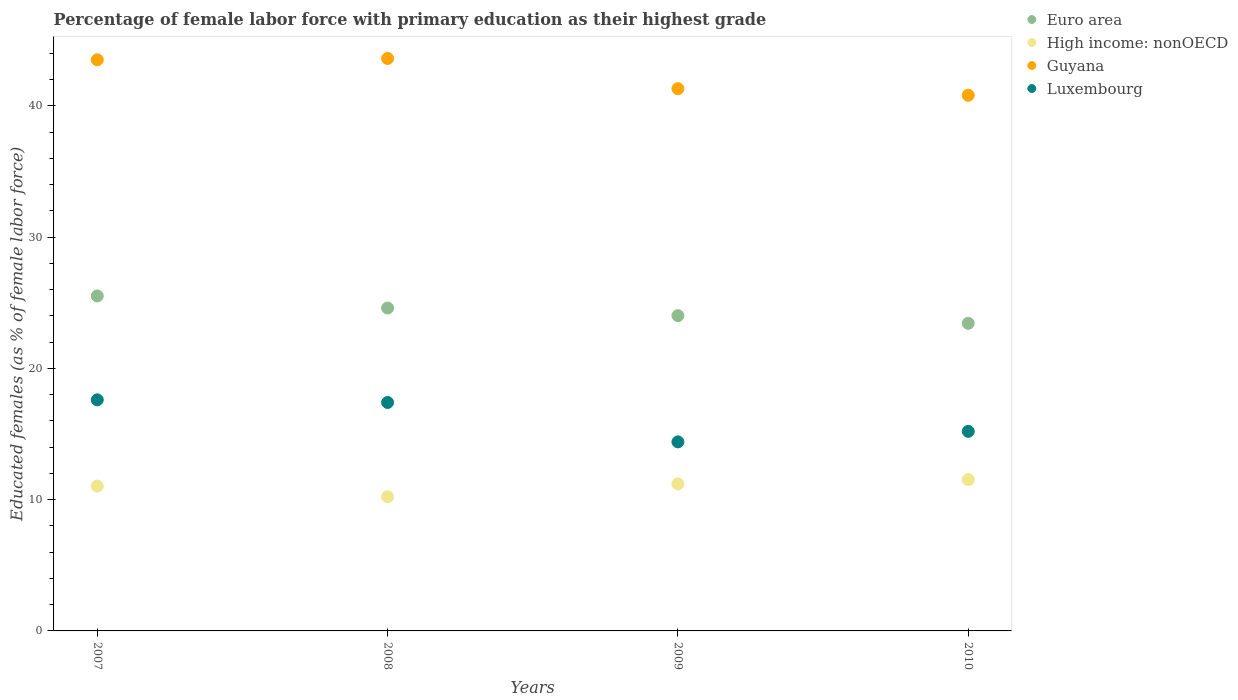What is the percentage of female labor force with primary education in Luxembourg in 2010?
Keep it short and to the point. 15.2. Across all years, what is the maximum percentage of female labor force with primary education in Euro area?
Offer a terse response. 25.51. Across all years, what is the minimum percentage of female labor force with primary education in Euro area?
Your response must be concise. 23.43. In which year was the percentage of female labor force with primary education in Luxembourg minimum?
Provide a short and direct response. 2009. What is the total percentage of female labor force with primary education in Euro area in the graph?
Provide a short and direct response. 97.55. What is the difference between the percentage of female labor force with primary education in Euro area in 2007 and that in 2009?
Your response must be concise. 1.5. What is the difference between the percentage of female labor force with primary education in Luxembourg in 2010 and the percentage of female labor force with primary education in High income: nonOECD in 2007?
Provide a short and direct response. 4.17. What is the average percentage of female labor force with primary education in Luxembourg per year?
Your answer should be very brief. 16.15. In the year 2009, what is the difference between the percentage of female labor force with primary education in Euro area and percentage of female labor force with primary education in Guyana?
Provide a short and direct response. -17.29. In how many years, is the percentage of female labor force with primary education in Luxembourg greater than 40 %?
Your response must be concise. 0. What is the ratio of the percentage of female labor force with primary education in Guyana in 2009 to that in 2010?
Give a very brief answer. 1.01. What is the difference between the highest and the second highest percentage of female labor force with primary education in Luxembourg?
Offer a terse response. 0.2. What is the difference between the highest and the lowest percentage of female labor force with primary education in Guyana?
Your answer should be compact. 2.8. Is the sum of the percentage of female labor force with primary education in High income: nonOECD in 2007 and 2010 greater than the maximum percentage of female labor force with primary education in Guyana across all years?
Provide a succinct answer. No. How many dotlines are there?
Your response must be concise. 4. What is the difference between two consecutive major ticks on the Y-axis?
Your answer should be compact. 10. Are the values on the major ticks of Y-axis written in scientific E-notation?
Offer a terse response. No. Does the graph contain any zero values?
Provide a succinct answer. No. What is the title of the graph?
Make the answer very short. Percentage of female labor force with primary education as their highest grade. Does "Cambodia" appear as one of the legend labels in the graph?
Offer a terse response. No. What is the label or title of the Y-axis?
Your answer should be very brief. Educated females (as % of female labor force). What is the Educated females (as % of female labor force) of Euro area in 2007?
Your answer should be compact. 25.51. What is the Educated females (as % of female labor force) of High income: nonOECD in 2007?
Offer a terse response. 11.03. What is the Educated females (as % of female labor force) in Guyana in 2007?
Keep it short and to the point. 43.5. What is the Educated females (as % of female labor force) of Luxembourg in 2007?
Provide a short and direct response. 17.6. What is the Educated females (as % of female labor force) in Euro area in 2008?
Provide a short and direct response. 24.59. What is the Educated females (as % of female labor force) in High income: nonOECD in 2008?
Keep it short and to the point. 10.21. What is the Educated females (as % of female labor force) of Guyana in 2008?
Offer a very short reply. 43.6. What is the Educated females (as % of female labor force) in Luxembourg in 2008?
Offer a very short reply. 17.4. What is the Educated females (as % of female labor force) of Euro area in 2009?
Offer a terse response. 24.01. What is the Educated females (as % of female labor force) of High income: nonOECD in 2009?
Your response must be concise. 11.2. What is the Educated females (as % of female labor force) of Guyana in 2009?
Offer a terse response. 41.3. What is the Educated females (as % of female labor force) in Luxembourg in 2009?
Provide a short and direct response. 14.4. What is the Educated females (as % of female labor force) in Euro area in 2010?
Your response must be concise. 23.43. What is the Educated females (as % of female labor force) in High income: nonOECD in 2010?
Your response must be concise. 11.53. What is the Educated females (as % of female labor force) of Guyana in 2010?
Ensure brevity in your answer.  40.8. What is the Educated females (as % of female labor force) in Luxembourg in 2010?
Give a very brief answer. 15.2. Across all years, what is the maximum Educated females (as % of female labor force) of Euro area?
Ensure brevity in your answer.  25.51. Across all years, what is the maximum Educated females (as % of female labor force) of High income: nonOECD?
Make the answer very short. 11.53. Across all years, what is the maximum Educated females (as % of female labor force) of Guyana?
Your response must be concise. 43.6. Across all years, what is the maximum Educated females (as % of female labor force) in Luxembourg?
Your answer should be very brief. 17.6. Across all years, what is the minimum Educated females (as % of female labor force) of Euro area?
Your response must be concise. 23.43. Across all years, what is the minimum Educated females (as % of female labor force) in High income: nonOECD?
Offer a very short reply. 10.21. Across all years, what is the minimum Educated females (as % of female labor force) of Guyana?
Your answer should be compact. 40.8. Across all years, what is the minimum Educated females (as % of female labor force) of Luxembourg?
Your answer should be compact. 14.4. What is the total Educated females (as % of female labor force) in Euro area in the graph?
Keep it short and to the point. 97.55. What is the total Educated females (as % of female labor force) in High income: nonOECD in the graph?
Your answer should be very brief. 43.97. What is the total Educated females (as % of female labor force) in Guyana in the graph?
Offer a very short reply. 169.2. What is the total Educated females (as % of female labor force) of Luxembourg in the graph?
Offer a terse response. 64.6. What is the difference between the Educated females (as % of female labor force) in Euro area in 2007 and that in 2008?
Make the answer very short. 0.92. What is the difference between the Educated females (as % of female labor force) of High income: nonOECD in 2007 and that in 2008?
Provide a succinct answer. 0.82. What is the difference between the Educated females (as % of female labor force) in Euro area in 2007 and that in 2009?
Your answer should be very brief. 1.5. What is the difference between the Educated females (as % of female labor force) in High income: nonOECD in 2007 and that in 2009?
Make the answer very short. -0.17. What is the difference between the Educated females (as % of female labor force) of Guyana in 2007 and that in 2009?
Provide a succinct answer. 2.2. What is the difference between the Educated females (as % of female labor force) of Euro area in 2007 and that in 2010?
Your answer should be very brief. 2.08. What is the difference between the Educated females (as % of female labor force) of High income: nonOECD in 2007 and that in 2010?
Give a very brief answer. -0.49. What is the difference between the Educated females (as % of female labor force) of Luxembourg in 2007 and that in 2010?
Your answer should be very brief. 2.4. What is the difference between the Educated females (as % of female labor force) of Euro area in 2008 and that in 2009?
Provide a succinct answer. 0.58. What is the difference between the Educated females (as % of female labor force) of High income: nonOECD in 2008 and that in 2009?
Offer a very short reply. -0.99. What is the difference between the Educated females (as % of female labor force) of Guyana in 2008 and that in 2009?
Provide a succinct answer. 2.3. What is the difference between the Educated females (as % of female labor force) of Luxembourg in 2008 and that in 2009?
Provide a short and direct response. 3. What is the difference between the Educated females (as % of female labor force) of Euro area in 2008 and that in 2010?
Make the answer very short. 1.17. What is the difference between the Educated females (as % of female labor force) of High income: nonOECD in 2008 and that in 2010?
Offer a terse response. -1.31. What is the difference between the Educated females (as % of female labor force) of Luxembourg in 2008 and that in 2010?
Make the answer very short. 2.2. What is the difference between the Educated females (as % of female labor force) of Euro area in 2009 and that in 2010?
Offer a very short reply. 0.58. What is the difference between the Educated females (as % of female labor force) of High income: nonOECD in 2009 and that in 2010?
Provide a succinct answer. -0.33. What is the difference between the Educated females (as % of female labor force) of Euro area in 2007 and the Educated females (as % of female labor force) of High income: nonOECD in 2008?
Your answer should be compact. 15.3. What is the difference between the Educated females (as % of female labor force) of Euro area in 2007 and the Educated females (as % of female labor force) of Guyana in 2008?
Your response must be concise. -18.09. What is the difference between the Educated females (as % of female labor force) in Euro area in 2007 and the Educated females (as % of female labor force) in Luxembourg in 2008?
Offer a very short reply. 8.11. What is the difference between the Educated females (as % of female labor force) in High income: nonOECD in 2007 and the Educated females (as % of female labor force) in Guyana in 2008?
Make the answer very short. -32.57. What is the difference between the Educated females (as % of female labor force) in High income: nonOECD in 2007 and the Educated females (as % of female labor force) in Luxembourg in 2008?
Keep it short and to the point. -6.37. What is the difference between the Educated females (as % of female labor force) of Guyana in 2007 and the Educated females (as % of female labor force) of Luxembourg in 2008?
Offer a very short reply. 26.1. What is the difference between the Educated females (as % of female labor force) in Euro area in 2007 and the Educated females (as % of female labor force) in High income: nonOECD in 2009?
Ensure brevity in your answer.  14.31. What is the difference between the Educated females (as % of female labor force) of Euro area in 2007 and the Educated females (as % of female labor force) of Guyana in 2009?
Keep it short and to the point. -15.79. What is the difference between the Educated females (as % of female labor force) of Euro area in 2007 and the Educated females (as % of female labor force) of Luxembourg in 2009?
Keep it short and to the point. 11.11. What is the difference between the Educated females (as % of female labor force) in High income: nonOECD in 2007 and the Educated females (as % of female labor force) in Guyana in 2009?
Offer a very short reply. -30.27. What is the difference between the Educated females (as % of female labor force) of High income: nonOECD in 2007 and the Educated females (as % of female labor force) of Luxembourg in 2009?
Provide a short and direct response. -3.37. What is the difference between the Educated females (as % of female labor force) in Guyana in 2007 and the Educated females (as % of female labor force) in Luxembourg in 2009?
Provide a succinct answer. 29.1. What is the difference between the Educated females (as % of female labor force) in Euro area in 2007 and the Educated females (as % of female labor force) in High income: nonOECD in 2010?
Your answer should be very brief. 13.99. What is the difference between the Educated females (as % of female labor force) in Euro area in 2007 and the Educated females (as % of female labor force) in Guyana in 2010?
Give a very brief answer. -15.29. What is the difference between the Educated females (as % of female labor force) in Euro area in 2007 and the Educated females (as % of female labor force) in Luxembourg in 2010?
Give a very brief answer. 10.31. What is the difference between the Educated females (as % of female labor force) of High income: nonOECD in 2007 and the Educated females (as % of female labor force) of Guyana in 2010?
Give a very brief answer. -29.77. What is the difference between the Educated females (as % of female labor force) in High income: nonOECD in 2007 and the Educated females (as % of female labor force) in Luxembourg in 2010?
Offer a terse response. -4.17. What is the difference between the Educated females (as % of female labor force) in Guyana in 2007 and the Educated females (as % of female labor force) in Luxembourg in 2010?
Make the answer very short. 28.3. What is the difference between the Educated females (as % of female labor force) in Euro area in 2008 and the Educated females (as % of female labor force) in High income: nonOECD in 2009?
Your answer should be very brief. 13.39. What is the difference between the Educated females (as % of female labor force) of Euro area in 2008 and the Educated females (as % of female labor force) of Guyana in 2009?
Make the answer very short. -16.71. What is the difference between the Educated females (as % of female labor force) in Euro area in 2008 and the Educated females (as % of female labor force) in Luxembourg in 2009?
Provide a succinct answer. 10.19. What is the difference between the Educated females (as % of female labor force) of High income: nonOECD in 2008 and the Educated females (as % of female labor force) of Guyana in 2009?
Provide a succinct answer. -31.09. What is the difference between the Educated females (as % of female labor force) in High income: nonOECD in 2008 and the Educated females (as % of female labor force) in Luxembourg in 2009?
Give a very brief answer. -4.19. What is the difference between the Educated females (as % of female labor force) of Guyana in 2008 and the Educated females (as % of female labor force) of Luxembourg in 2009?
Offer a very short reply. 29.2. What is the difference between the Educated females (as % of female labor force) in Euro area in 2008 and the Educated females (as % of female labor force) in High income: nonOECD in 2010?
Keep it short and to the point. 13.07. What is the difference between the Educated females (as % of female labor force) in Euro area in 2008 and the Educated females (as % of female labor force) in Guyana in 2010?
Make the answer very short. -16.21. What is the difference between the Educated females (as % of female labor force) of Euro area in 2008 and the Educated females (as % of female labor force) of Luxembourg in 2010?
Provide a succinct answer. 9.39. What is the difference between the Educated females (as % of female labor force) in High income: nonOECD in 2008 and the Educated females (as % of female labor force) in Guyana in 2010?
Keep it short and to the point. -30.59. What is the difference between the Educated females (as % of female labor force) of High income: nonOECD in 2008 and the Educated females (as % of female labor force) of Luxembourg in 2010?
Provide a succinct answer. -4.99. What is the difference between the Educated females (as % of female labor force) of Guyana in 2008 and the Educated females (as % of female labor force) of Luxembourg in 2010?
Provide a short and direct response. 28.4. What is the difference between the Educated females (as % of female labor force) in Euro area in 2009 and the Educated females (as % of female labor force) in High income: nonOECD in 2010?
Give a very brief answer. 12.49. What is the difference between the Educated females (as % of female labor force) of Euro area in 2009 and the Educated females (as % of female labor force) of Guyana in 2010?
Your answer should be very brief. -16.79. What is the difference between the Educated females (as % of female labor force) of Euro area in 2009 and the Educated females (as % of female labor force) of Luxembourg in 2010?
Your answer should be very brief. 8.81. What is the difference between the Educated females (as % of female labor force) in High income: nonOECD in 2009 and the Educated females (as % of female labor force) in Guyana in 2010?
Offer a terse response. -29.6. What is the difference between the Educated females (as % of female labor force) of High income: nonOECD in 2009 and the Educated females (as % of female labor force) of Luxembourg in 2010?
Your response must be concise. -4. What is the difference between the Educated females (as % of female labor force) in Guyana in 2009 and the Educated females (as % of female labor force) in Luxembourg in 2010?
Provide a short and direct response. 26.1. What is the average Educated females (as % of female labor force) in Euro area per year?
Ensure brevity in your answer.  24.39. What is the average Educated females (as % of female labor force) in High income: nonOECD per year?
Your answer should be compact. 10.99. What is the average Educated females (as % of female labor force) in Guyana per year?
Keep it short and to the point. 42.3. What is the average Educated females (as % of female labor force) in Luxembourg per year?
Ensure brevity in your answer.  16.15. In the year 2007, what is the difference between the Educated females (as % of female labor force) in Euro area and Educated females (as % of female labor force) in High income: nonOECD?
Your answer should be very brief. 14.48. In the year 2007, what is the difference between the Educated females (as % of female labor force) of Euro area and Educated females (as % of female labor force) of Guyana?
Keep it short and to the point. -17.99. In the year 2007, what is the difference between the Educated females (as % of female labor force) in Euro area and Educated females (as % of female labor force) in Luxembourg?
Offer a terse response. 7.91. In the year 2007, what is the difference between the Educated females (as % of female labor force) of High income: nonOECD and Educated females (as % of female labor force) of Guyana?
Offer a terse response. -32.47. In the year 2007, what is the difference between the Educated females (as % of female labor force) in High income: nonOECD and Educated females (as % of female labor force) in Luxembourg?
Your response must be concise. -6.57. In the year 2007, what is the difference between the Educated females (as % of female labor force) in Guyana and Educated females (as % of female labor force) in Luxembourg?
Offer a very short reply. 25.9. In the year 2008, what is the difference between the Educated females (as % of female labor force) in Euro area and Educated females (as % of female labor force) in High income: nonOECD?
Give a very brief answer. 14.38. In the year 2008, what is the difference between the Educated females (as % of female labor force) of Euro area and Educated females (as % of female labor force) of Guyana?
Your answer should be compact. -19.01. In the year 2008, what is the difference between the Educated females (as % of female labor force) in Euro area and Educated females (as % of female labor force) in Luxembourg?
Your answer should be very brief. 7.19. In the year 2008, what is the difference between the Educated females (as % of female labor force) of High income: nonOECD and Educated females (as % of female labor force) of Guyana?
Provide a short and direct response. -33.39. In the year 2008, what is the difference between the Educated females (as % of female labor force) in High income: nonOECD and Educated females (as % of female labor force) in Luxembourg?
Keep it short and to the point. -7.19. In the year 2008, what is the difference between the Educated females (as % of female labor force) in Guyana and Educated females (as % of female labor force) in Luxembourg?
Your answer should be compact. 26.2. In the year 2009, what is the difference between the Educated females (as % of female labor force) in Euro area and Educated females (as % of female labor force) in High income: nonOECD?
Provide a short and direct response. 12.81. In the year 2009, what is the difference between the Educated females (as % of female labor force) of Euro area and Educated females (as % of female labor force) of Guyana?
Keep it short and to the point. -17.29. In the year 2009, what is the difference between the Educated females (as % of female labor force) of Euro area and Educated females (as % of female labor force) of Luxembourg?
Your answer should be compact. 9.61. In the year 2009, what is the difference between the Educated females (as % of female labor force) in High income: nonOECD and Educated females (as % of female labor force) in Guyana?
Provide a short and direct response. -30.1. In the year 2009, what is the difference between the Educated females (as % of female labor force) in High income: nonOECD and Educated females (as % of female labor force) in Luxembourg?
Offer a very short reply. -3.2. In the year 2009, what is the difference between the Educated females (as % of female labor force) of Guyana and Educated females (as % of female labor force) of Luxembourg?
Provide a short and direct response. 26.9. In the year 2010, what is the difference between the Educated females (as % of female labor force) in Euro area and Educated females (as % of female labor force) in High income: nonOECD?
Keep it short and to the point. 11.9. In the year 2010, what is the difference between the Educated females (as % of female labor force) in Euro area and Educated females (as % of female labor force) in Guyana?
Your response must be concise. -17.37. In the year 2010, what is the difference between the Educated females (as % of female labor force) in Euro area and Educated females (as % of female labor force) in Luxembourg?
Give a very brief answer. 8.23. In the year 2010, what is the difference between the Educated females (as % of female labor force) in High income: nonOECD and Educated females (as % of female labor force) in Guyana?
Keep it short and to the point. -29.27. In the year 2010, what is the difference between the Educated females (as % of female labor force) in High income: nonOECD and Educated females (as % of female labor force) in Luxembourg?
Your answer should be compact. -3.67. In the year 2010, what is the difference between the Educated females (as % of female labor force) of Guyana and Educated females (as % of female labor force) of Luxembourg?
Provide a short and direct response. 25.6. What is the ratio of the Educated females (as % of female labor force) in Euro area in 2007 to that in 2008?
Keep it short and to the point. 1.04. What is the ratio of the Educated females (as % of female labor force) of High income: nonOECD in 2007 to that in 2008?
Your response must be concise. 1.08. What is the ratio of the Educated females (as % of female labor force) in Luxembourg in 2007 to that in 2008?
Offer a terse response. 1.01. What is the ratio of the Educated females (as % of female labor force) in Euro area in 2007 to that in 2009?
Make the answer very short. 1.06. What is the ratio of the Educated females (as % of female labor force) in Guyana in 2007 to that in 2009?
Your answer should be compact. 1.05. What is the ratio of the Educated females (as % of female labor force) in Luxembourg in 2007 to that in 2009?
Provide a short and direct response. 1.22. What is the ratio of the Educated females (as % of female labor force) of Euro area in 2007 to that in 2010?
Provide a short and direct response. 1.09. What is the ratio of the Educated females (as % of female labor force) of High income: nonOECD in 2007 to that in 2010?
Make the answer very short. 0.96. What is the ratio of the Educated females (as % of female labor force) in Guyana in 2007 to that in 2010?
Your answer should be very brief. 1.07. What is the ratio of the Educated females (as % of female labor force) of Luxembourg in 2007 to that in 2010?
Give a very brief answer. 1.16. What is the ratio of the Educated females (as % of female labor force) of Euro area in 2008 to that in 2009?
Provide a succinct answer. 1.02. What is the ratio of the Educated females (as % of female labor force) in High income: nonOECD in 2008 to that in 2009?
Ensure brevity in your answer.  0.91. What is the ratio of the Educated females (as % of female labor force) in Guyana in 2008 to that in 2009?
Provide a short and direct response. 1.06. What is the ratio of the Educated females (as % of female labor force) in Luxembourg in 2008 to that in 2009?
Your response must be concise. 1.21. What is the ratio of the Educated females (as % of female labor force) of Euro area in 2008 to that in 2010?
Your answer should be compact. 1.05. What is the ratio of the Educated females (as % of female labor force) of High income: nonOECD in 2008 to that in 2010?
Your response must be concise. 0.89. What is the ratio of the Educated females (as % of female labor force) of Guyana in 2008 to that in 2010?
Keep it short and to the point. 1.07. What is the ratio of the Educated females (as % of female labor force) in Luxembourg in 2008 to that in 2010?
Offer a very short reply. 1.14. What is the ratio of the Educated females (as % of female labor force) of High income: nonOECD in 2009 to that in 2010?
Your answer should be compact. 0.97. What is the ratio of the Educated females (as % of female labor force) of Guyana in 2009 to that in 2010?
Provide a succinct answer. 1.01. What is the difference between the highest and the second highest Educated females (as % of female labor force) of Euro area?
Provide a succinct answer. 0.92. What is the difference between the highest and the second highest Educated females (as % of female labor force) in High income: nonOECD?
Offer a terse response. 0.33. What is the difference between the highest and the second highest Educated females (as % of female labor force) of Guyana?
Keep it short and to the point. 0.1. What is the difference between the highest and the second highest Educated females (as % of female labor force) in Luxembourg?
Offer a terse response. 0.2. What is the difference between the highest and the lowest Educated females (as % of female labor force) of Euro area?
Offer a very short reply. 2.08. What is the difference between the highest and the lowest Educated females (as % of female labor force) in High income: nonOECD?
Provide a short and direct response. 1.31. What is the difference between the highest and the lowest Educated females (as % of female labor force) of Guyana?
Keep it short and to the point. 2.8. What is the difference between the highest and the lowest Educated females (as % of female labor force) in Luxembourg?
Your answer should be compact. 3.2. 